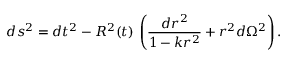Convert formula to latex. <formula><loc_0><loc_0><loc_500><loc_500>d s ^ { 2 } = d t ^ { 2 } - R ^ { 2 } ( t ) \, \left ( \frac { d r ^ { 2 } } { 1 - k r ^ { 2 } } + r ^ { 2 } d \Omega ^ { 2 } \right ) .</formula> 